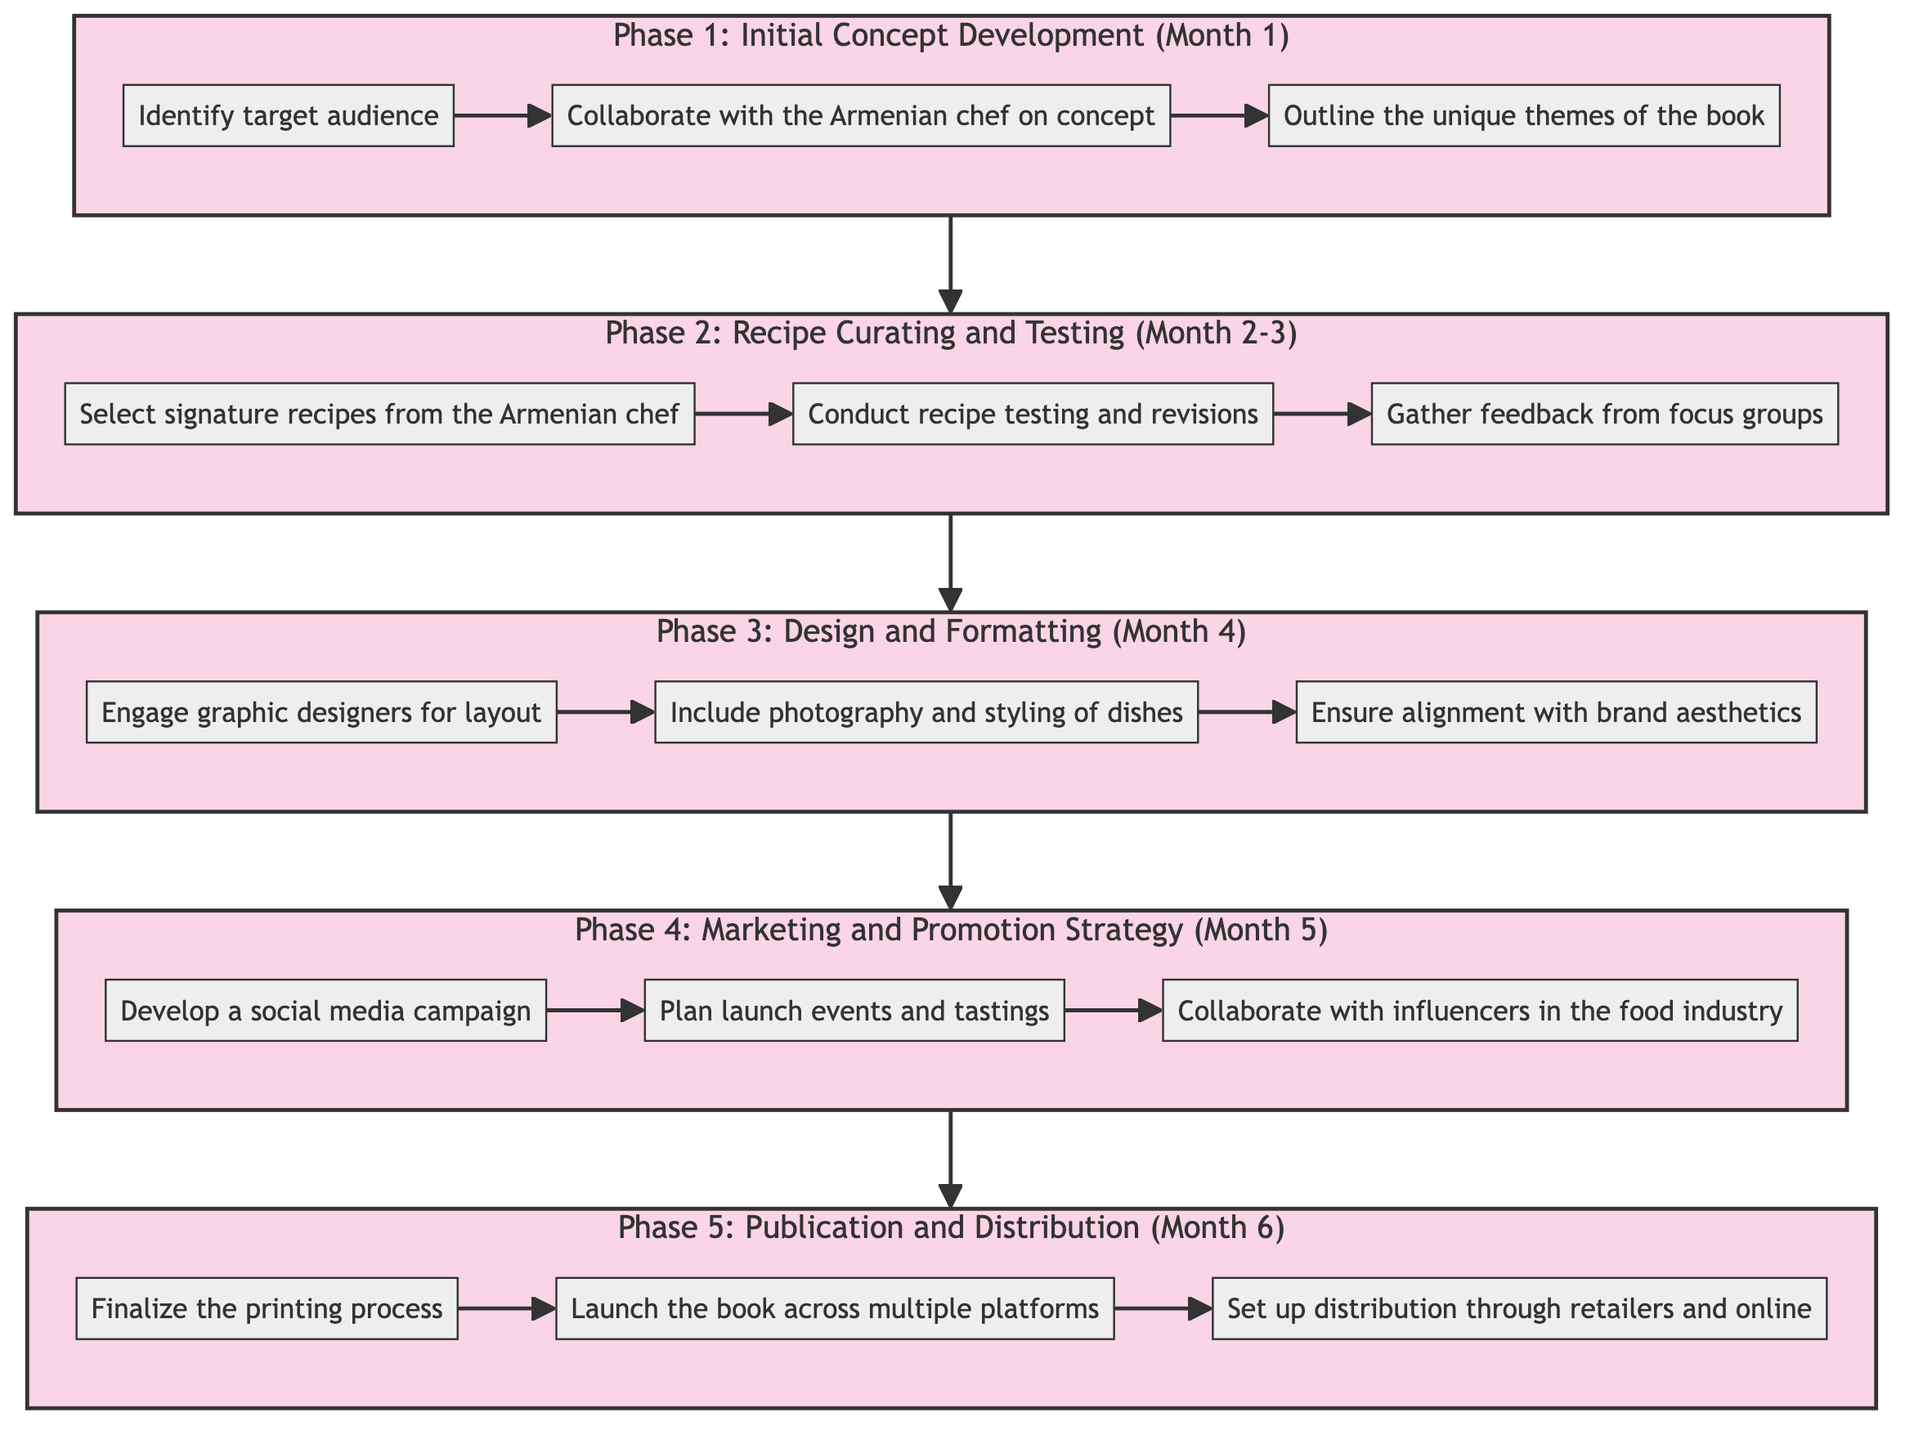What is the total number of phases in the timeline? The diagram lists five distinct phases: Initial Concept Development, Recipe Curating and Testing, Design and Formatting, Marketing and Promotion Strategy, and Publication and Distribution. Therefore, when counting them, the total is five.
Answer: 5 What duration does Phase 3 cover? According to the diagram, Phase 3 is titled "Design and Formatting" and is specified to last for "Month 4." Therefore, the duration is clearly defined as Month 4.
Answer: Month 4 Which phase comes directly before "Publication and Distribution"? By examining the flow of the diagram, Phase 4 is designated as "Marketing and Promotion Strategy," and it leads directly into Phase 5, which is "Publication and Distribution." Thus, the phase that comes directly before is Marketing and Promotion Strategy.
Answer: Marketing and Promotion Strategy What activity is included in Phase 1? Phase 1 is titled "Initial Concept Development." The activities listed under this phase are: Identify target audience, Collaborate with the Armenian chef on concept, and Outline the unique themes of the book. Any of these activities is included in Phase 1, but one specific activity chosen is "Identify target audience."
Answer: Identify target audience What are the last three activities listed in the timeline? The last phase is Phase 5 titled "Publication and Distribution," with the activities defined as: Finalize the printing process, Launch the book across multiple platforms, and Set up distribution through retailers and online. Therefore, the last three activities are all part of this final phase, and we identify them as follows: Finalize the printing process, Launch the book across multiple platforms, Set up distribution through retailers and online.
Answer: Finalize the printing process, Launch the book across multiple platforms, Set up distribution through retailers and online Which phase includes developing a social media campaign? The diagram indicates that a social media campaign is part of Phase 4. This phase is titled "Marketing and Promotion Strategy" which specifically mentions the development of a social media campaign as one of its activities. Therefore, the phase that includes this activity is Phase 4.
Answer: Marketing and Promotion Strategy How many activities are listed in Phase 2? In Phase 2, which is titled "Recipe Curating and Testing," there are three activities detailed: Select signature recipes from the Armenian chef, Conduct recipe testing and revisions, and Gather feedback from focus groups. Counting these, we find there are three activities in Phase 2.
Answer: 3 What is the first activity in the timeline? Referring to Phase 1 of the diagram, the first activity listed is "Identify target audience." This establishes it as the initial activity in the overall timeline for the co-branded recipe book.
Answer: Identify target audience 